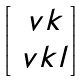Convert formula to latex. <formula><loc_0><loc_0><loc_500><loc_500>\begin{bmatrix} \ v k \\ \ v k l \end{bmatrix}</formula> 